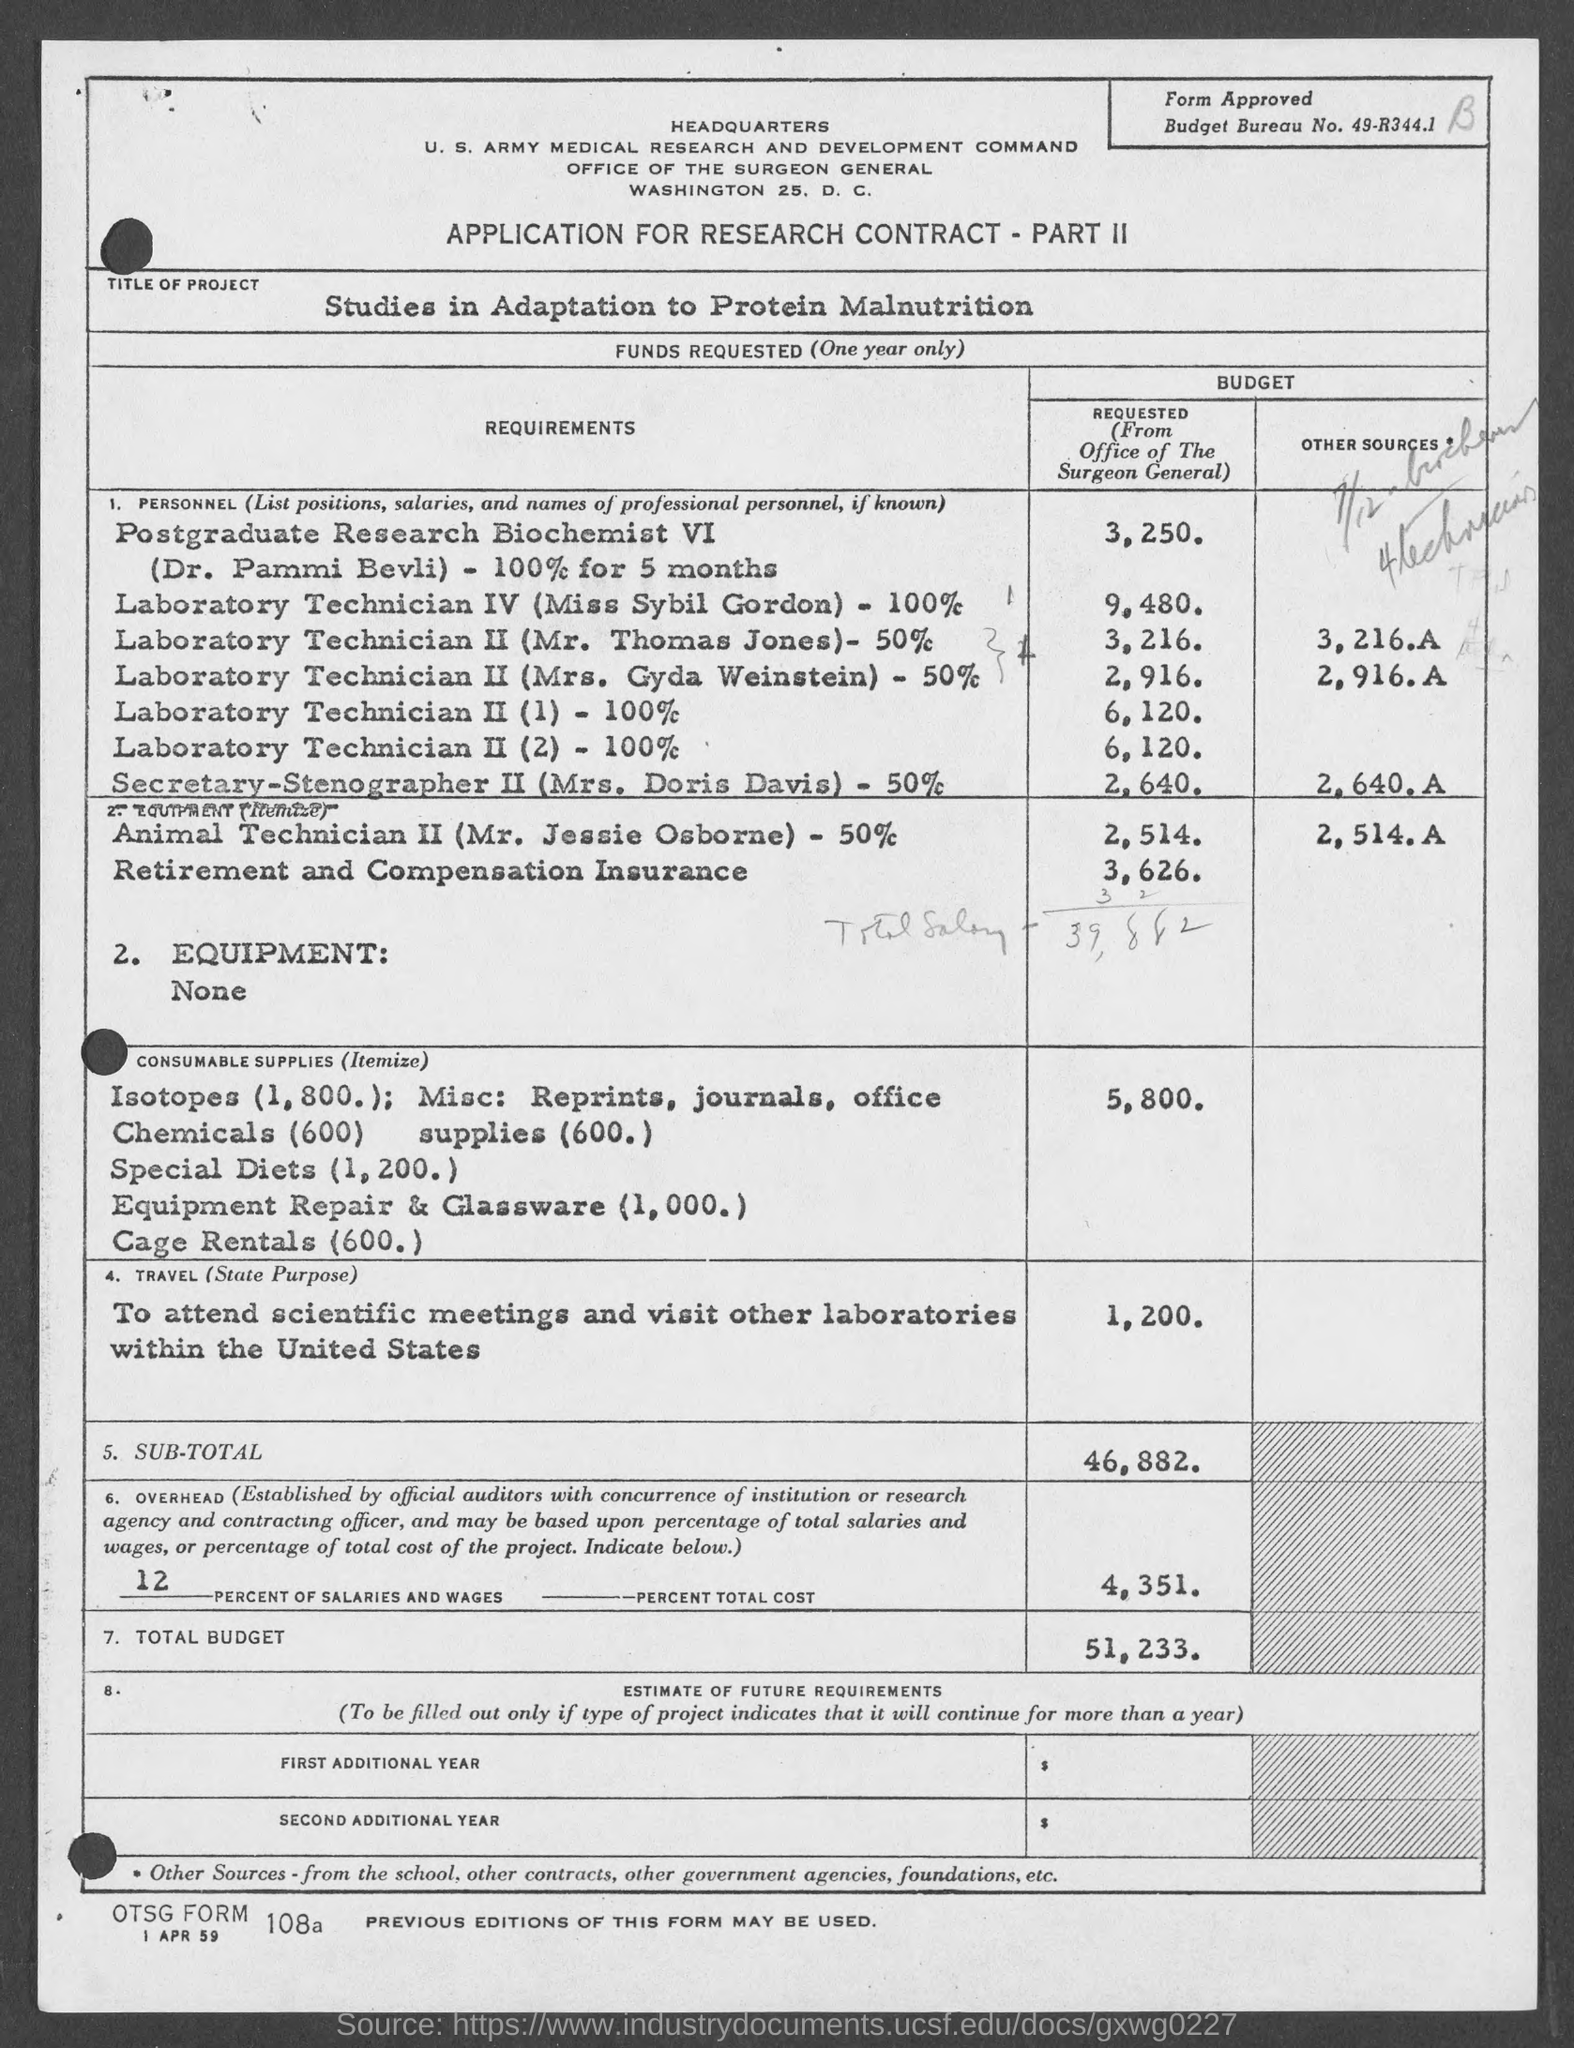Draw attention to some important aspects in this diagram. The budget bureau number is 49-R344.1... The project is titled 'Studies in Adaptation to Protein Malnutrition.' The application is about obtaining a research contract for the purpose of conducting research on a particular topic. 